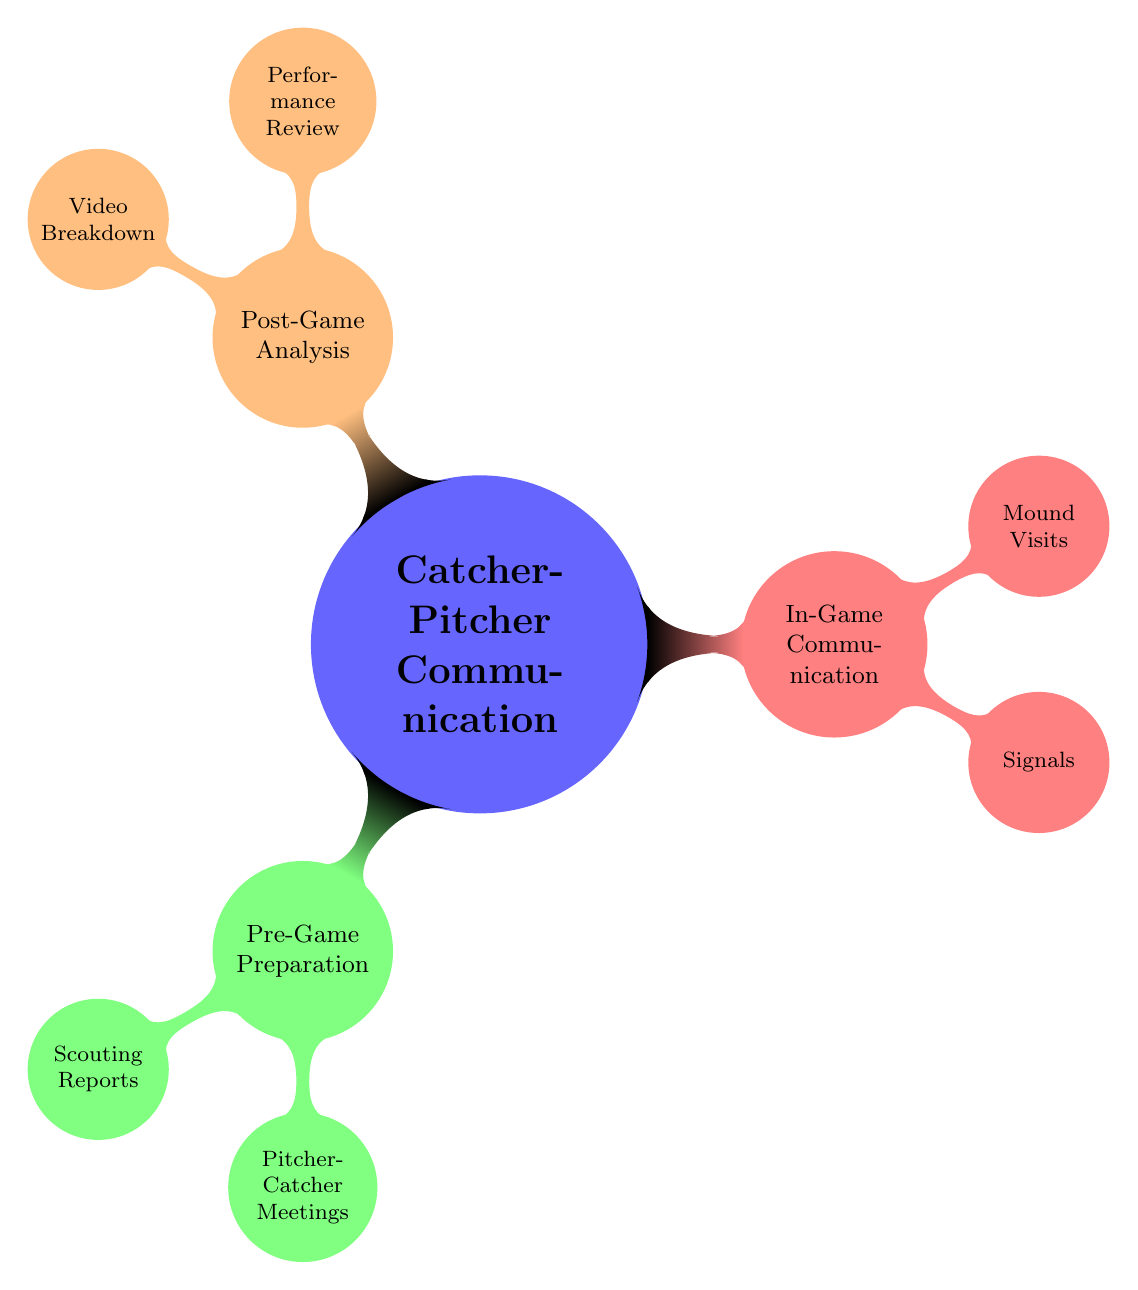What are the three main categories of communication methods? The diagram shows three main categories under "Catcher-Pitcher Communication Methods": Pre-Game Preparation, In-Game Communication, and Post-Game Analysis.
Answer: Pre-Game Preparation, In-Game Communication, Post-Game Analysis How many nodes are under "In-Game Communication"? Under "In-Game Communication," there are two nodes: Signals and Mound Visits. Therefore, counting them gives us a total of two nodes.
Answer: 2 What type of discussion occurs during Pitcher-Catcher Meetings? Within the node "Pitcher-Catcher Meetings," the diagram specifies two types of discussions: "Strategy Discussion" and "Signal Review."
Answer: Strategy Discussion, Signal Review What feedback is provided during Performance Review? In the "Performance Review" section, it specifies that "Catcher Feedback" is provided alongside "Pitcher Feedback."
Answer: Catcher Feedback, Pitcher Feedback Which method involves assessing batters' strengths? The node "Opponent Analysis" specifically mentions assessing batters' strengths and weaknesses, indicating that this method involves a detailed assessment of the opponents.
Answer: Assessing batters' strengths and weaknesses Which communication method includes hand gestures? The section labeled "Signals" directly states that it includes "Hand Signals," which refers to using hand gestures to indicate pitch types and locations.
Answer: Hand Signals What is the purpose of "Mound Visits"? "Mound Visits" serve two purposes: to conduct "Quick Talks" for strategy discussions or to provide "Extended Discussions" during high-pressure situations.
Answer: Quick Talks, Extended Discussions What type of analysis is done post-game according to the diagram? The diagram lists "Video Breakdown" as a means of post-game analysis, which involves reviewing game footage for insights and adjustments.
Answer: Video Breakdown How do catchers and pitchers communicate during the game? The communication during the game occurs through "Signals" like hand gestures and body language, and through "Mound Visits" for brief discussions.
Answer: Signals and Mound Visits 